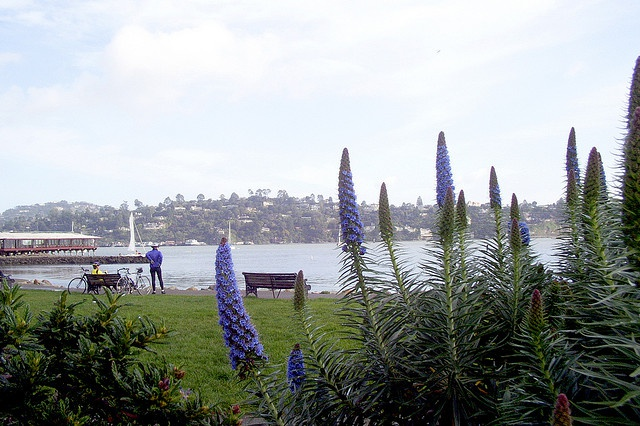Describe the objects in this image and their specific colors. I can see bench in white, black, gray, purple, and navy tones, bicycle in white, gray, darkgray, lightgray, and black tones, bench in white, black, gray, purple, and maroon tones, people in white, navy, black, and blue tones, and bicycle in white, gray, darkgray, black, and lightgray tones in this image. 